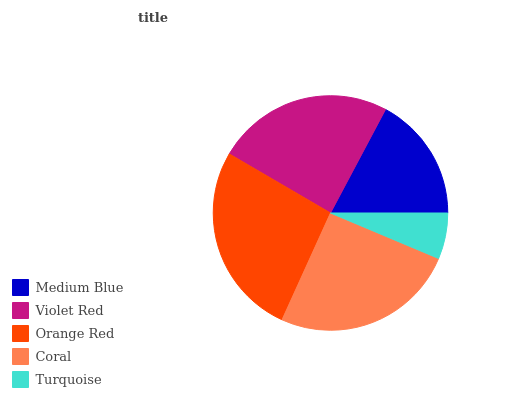Is Turquoise the minimum?
Answer yes or no. Yes. Is Orange Red the maximum?
Answer yes or no. Yes. Is Violet Red the minimum?
Answer yes or no. No. Is Violet Red the maximum?
Answer yes or no. No. Is Violet Red greater than Medium Blue?
Answer yes or no. Yes. Is Medium Blue less than Violet Red?
Answer yes or no. Yes. Is Medium Blue greater than Violet Red?
Answer yes or no. No. Is Violet Red less than Medium Blue?
Answer yes or no. No. Is Violet Red the high median?
Answer yes or no. Yes. Is Violet Red the low median?
Answer yes or no. Yes. Is Orange Red the high median?
Answer yes or no. No. Is Orange Red the low median?
Answer yes or no. No. 